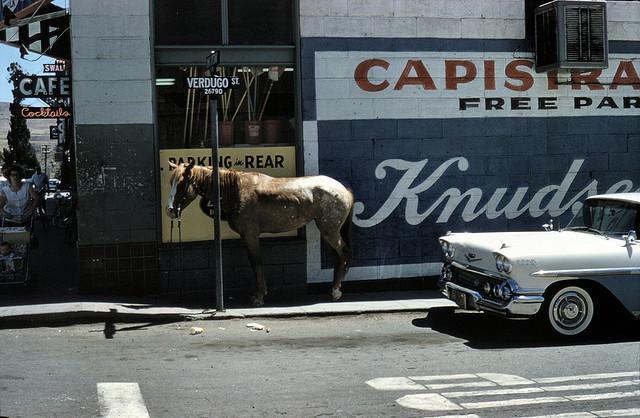This animal is frequently used as transportation by what profession?
Make your selection from the four choices given to correctly answer the question.
Options: Plumber, police officer, butcher, baker. Police officer. 